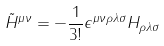Convert formula to latex. <formula><loc_0><loc_0><loc_500><loc_500>\tilde { H } ^ { \mu \nu } = - \frac { 1 } { 3 ! } \epsilon ^ { \mu \nu \rho \lambda \sigma } H _ { \rho \lambda \sigma }</formula> 